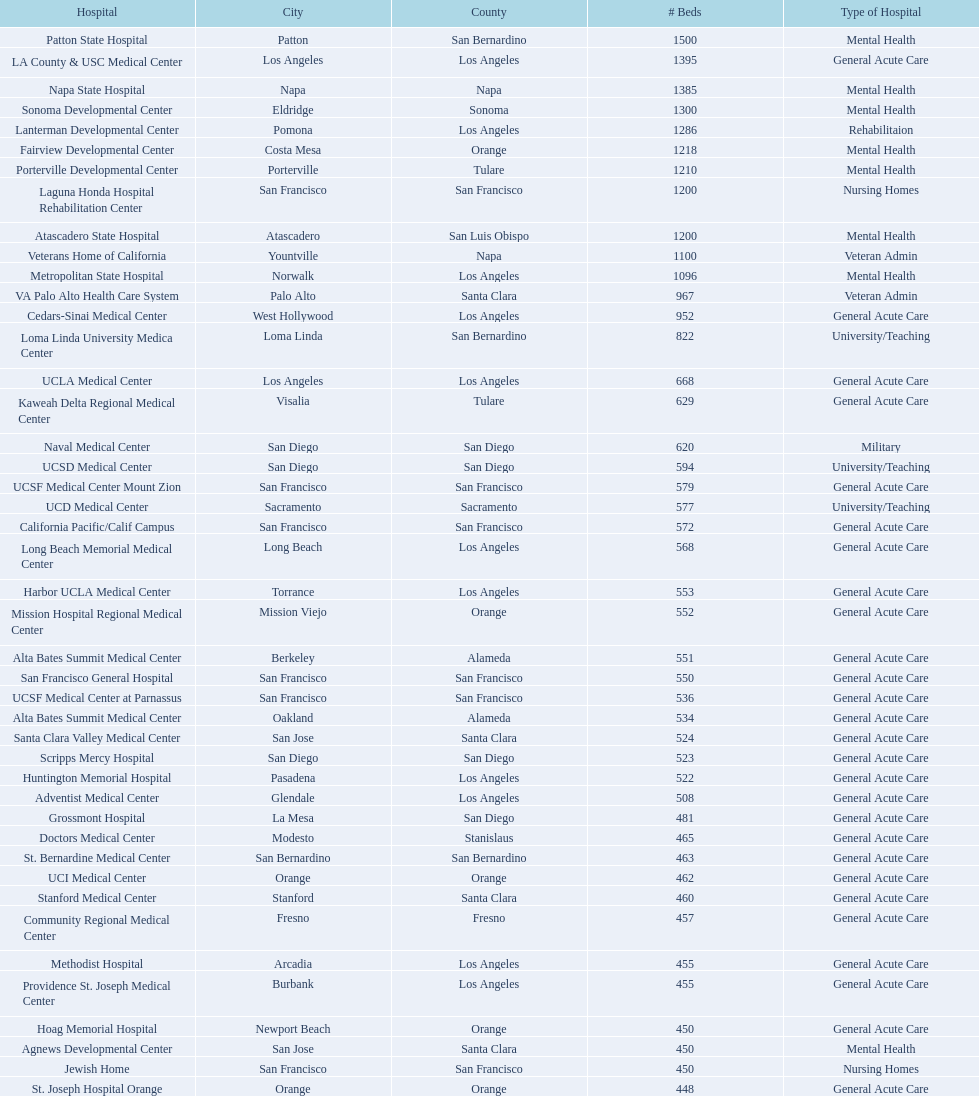Does patton state hospital in the city of patton in san bernardino county have more mental health hospital beds than atascadero state hospital in atascadero, san luis obispo county? Yes. 